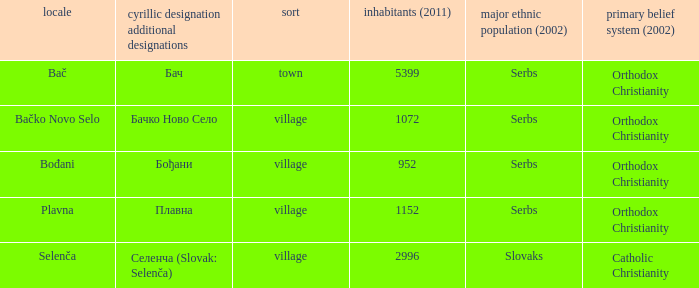What is the second way of writting плавна. Plavna. 